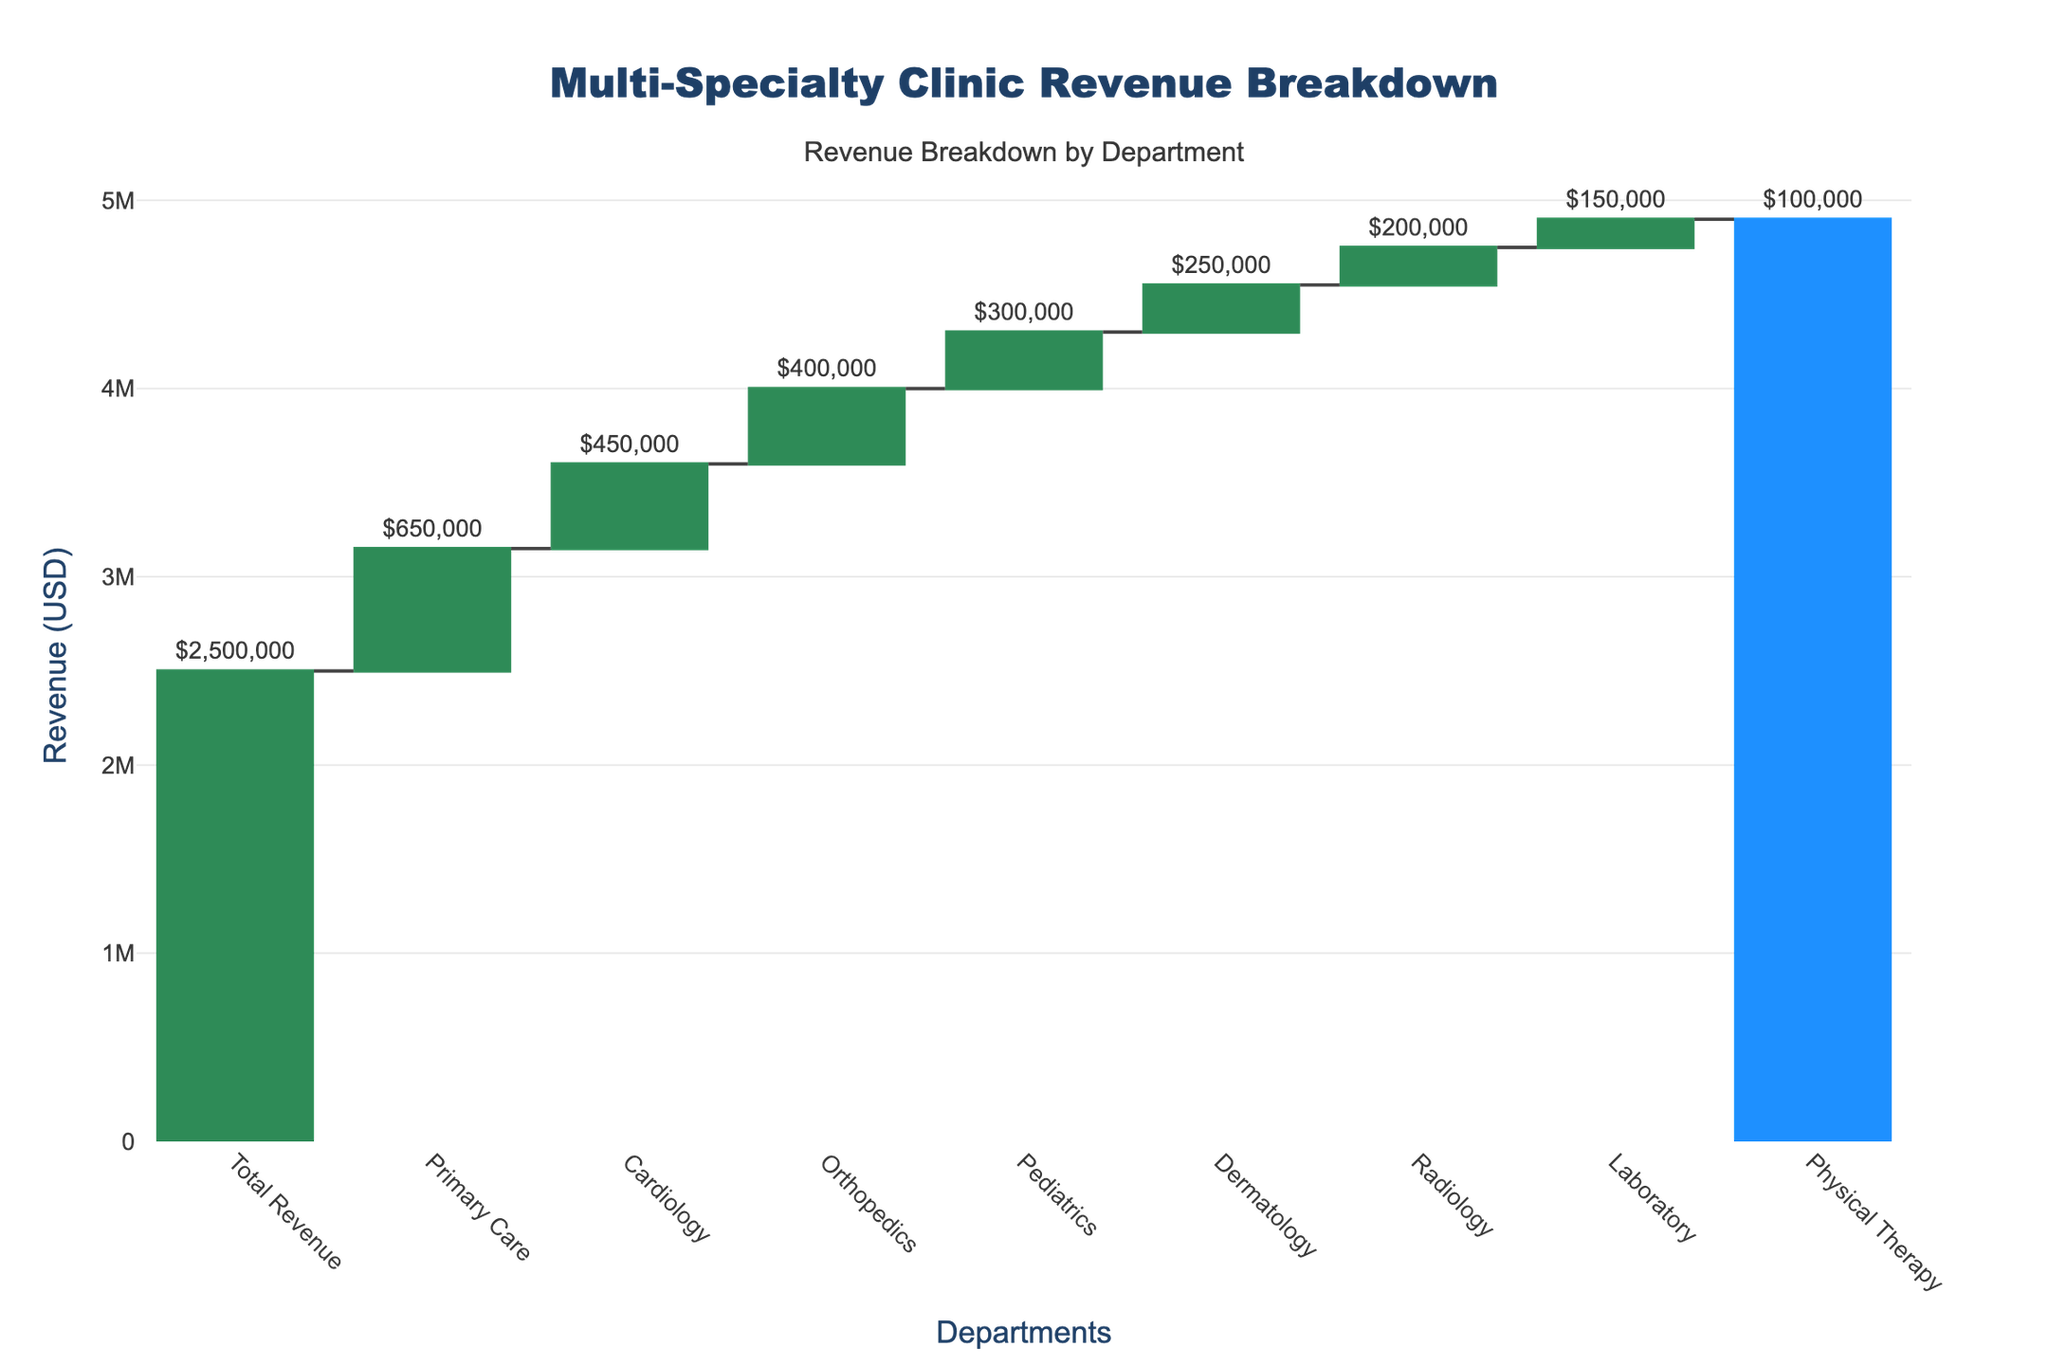What is the title of the chart? The title is at the top center of the chart and is clearly labeled "Multi-Specialty Clinic Revenue Breakdown."
Answer: Multi-Specialty Clinic Revenue Breakdown Which department has the highest revenue decrease? By looking at the waterfall's highest red bar, we can see that Primary Care has the highest revenue decrease.
Answer: Primary Care What is the total revenue of the multi-specialty clinic? The green bar labeled "Total Revenue" at the starting position shows the total revenue amount, which is $2,500,000.
Answer: $2,500,000 How much revenue did the Radiology department generate? The length of the blue bar corresponding to Radiology represents its revenue, which is $200,000.
Answer: $200,000 What is the combined revenue decrease of the Orthopedics and Cardiology departments? Adding the revenue decreases of Orthopedics ($400,000) and Cardiology ($450,000) gives us $850,000.
Answer: $850,000 Which department contributes the least to the total revenue? By locating the smallest blue bar, we can see that Physical Therapy has the smallest contribution to total revenue, which is $100,000.
Answer: Physical Therapy What is the difference in revenue between the Pediatrics and Dermatology departments? Subtract the revenue of Dermatology ($250,000) from Pediatrics ($300,000) to find the difference, which is $50,000.
Answer: $50,000 Which department has a higher revenue, Laboratory or Dermatology? By comparing the lengths of the blue bars for Laboratory ($150,000) and Dermatology ($250,000), we find that Dermatology has higher revenue.
Answer: Dermatology If the Physical Therapy department's revenue increase by $40,000, what would be its new total revenue? Add $40,000 to the current Physical Therapy revenue ($100,000) to get the new total, which is $140,000.
Answer: $140,000 What is the sum of revenues generated by Primary Care, Cardiology, and Orthopedics departments? Adding revenues of Primary Care ($650,000), Cardiology ($450,000), and Orthopedics ($400,000) results in $1,500,000.
Answer: $1,500,000 